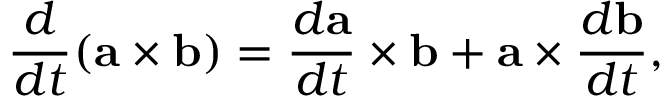<formula> <loc_0><loc_0><loc_500><loc_500>{ \frac { d } { d t } } ( a \times b ) = { \frac { d a } { d t } } \times b + a \times { \frac { d b } { d t } } ,</formula> 